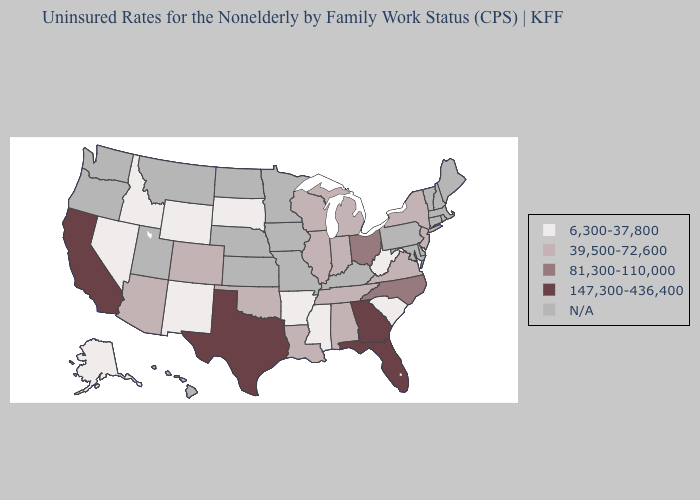What is the value of Minnesota?
Give a very brief answer. N/A. Among the states that border Wyoming , which have the lowest value?
Write a very short answer. Idaho, South Dakota. Which states have the highest value in the USA?
Answer briefly. California, Florida, Georgia, Texas. Among the states that border Pennsylvania , does Ohio have the lowest value?
Keep it brief. No. What is the lowest value in the South?
Give a very brief answer. 6,300-37,800. Among the states that border Louisiana , does Arkansas have the lowest value?
Give a very brief answer. Yes. Name the states that have a value in the range 81,300-110,000?
Be succinct. North Carolina, Ohio. Does Mississippi have the lowest value in the South?
Concise answer only. Yes. Name the states that have a value in the range 147,300-436,400?
Short answer required. California, Florida, Georgia, Texas. Among the states that border Nevada , does Idaho have the lowest value?
Keep it brief. Yes. Does the first symbol in the legend represent the smallest category?
Be succinct. Yes. Name the states that have a value in the range 81,300-110,000?
Concise answer only. North Carolina, Ohio. What is the value of Hawaii?
Concise answer only. N/A. Name the states that have a value in the range 39,500-72,600?
Write a very short answer. Alabama, Arizona, Colorado, Illinois, Indiana, Louisiana, Michigan, New Jersey, New York, Oklahoma, Tennessee, Virginia, Wisconsin. 